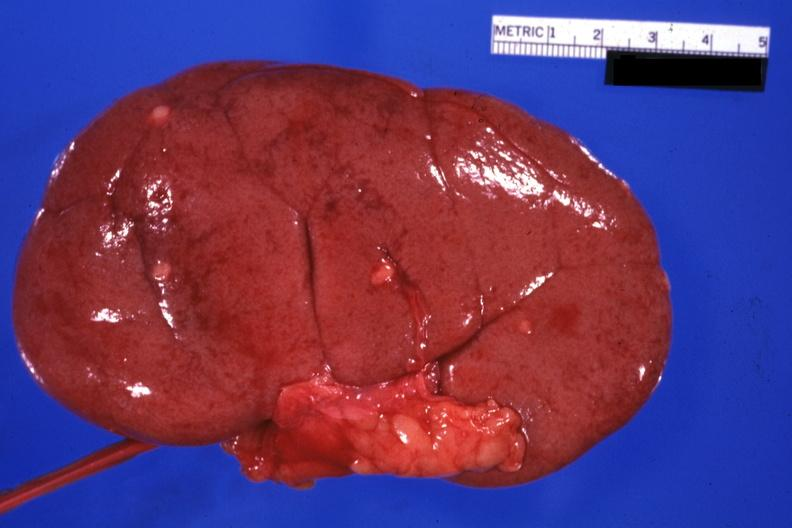does larynx show external view with capsule removed small lesions easily seen?
Answer the question using a single word or phrase. No 